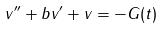Convert formula to latex. <formula><loc_0><loc_0><loc_500><loc_500>v ^ { \prime \prime } + b v ^ { \prime } + v = - G ( t )</formula> 